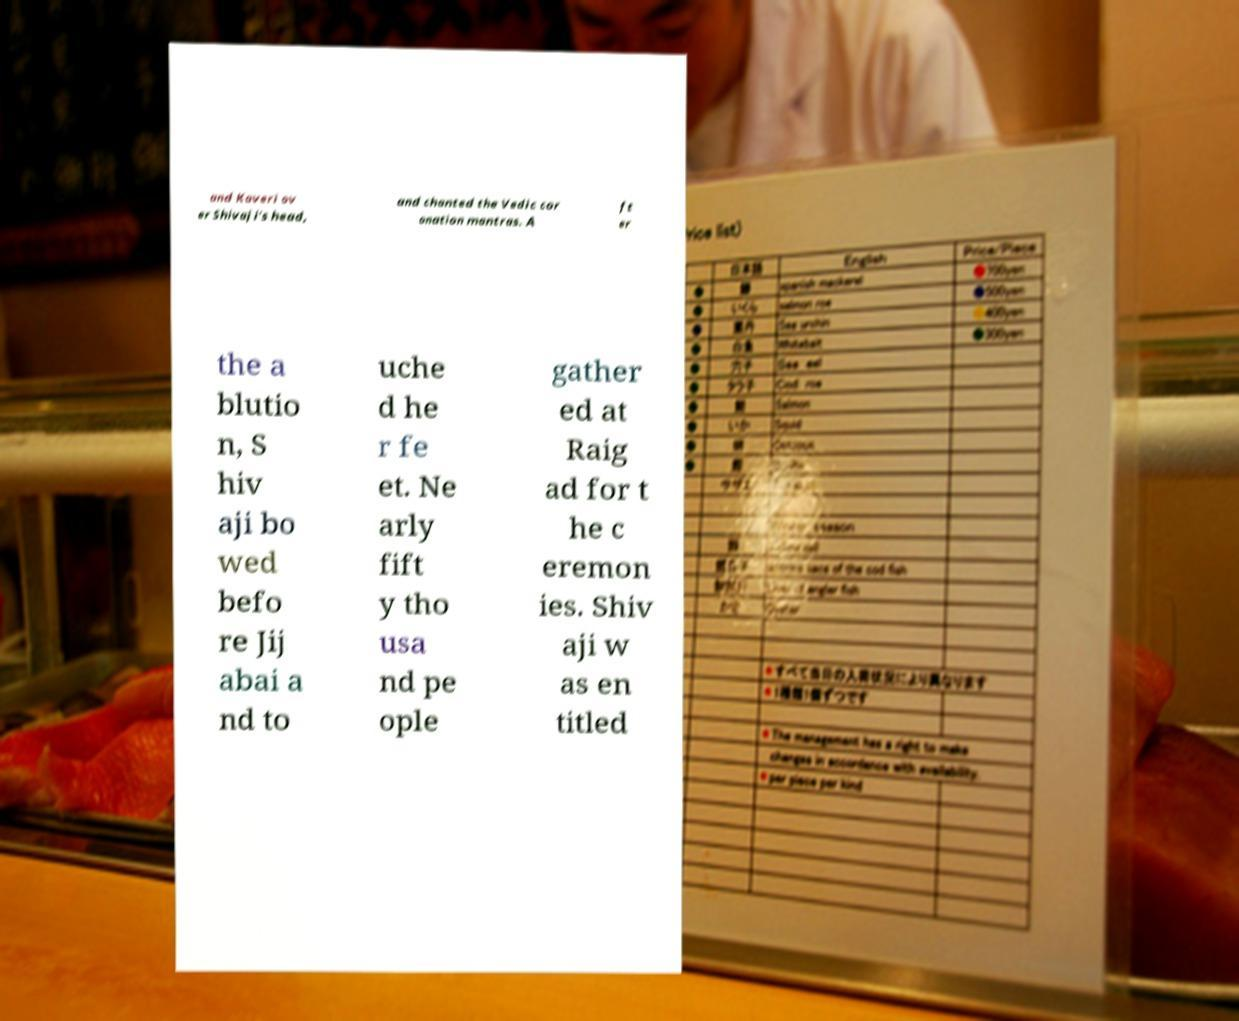I need the written content from this picture converted into text. Can you do that? and Kaveri ov er Shivaji's head, and chanted the Vedic cor onation mantras. A ft er the a blutio n, S hiv aji bo wed befo re Jij abai a nd to uche d he r fe et. Ne arly fift y tho usa nd pe ople gather ed at Raig ad for t he c eremon ies. Shiv aji w as en titled 